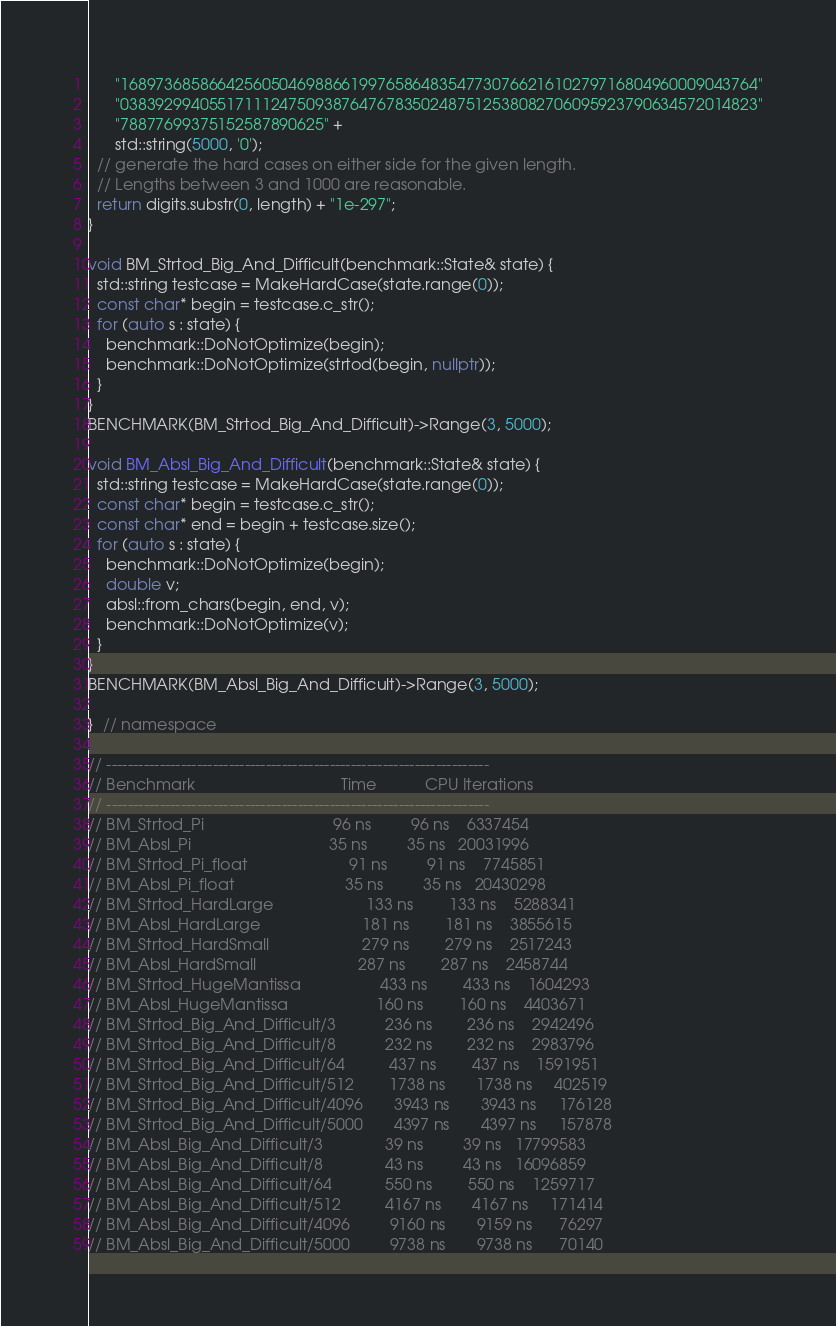<code> <loc_0><loc_0><loc_500><loc_500><_C++_>      "168973685866425605046988661997658648354773076621610279716804960009043764"
      "038392994055171112475093876476783502487512538082706095923790634572014823"
      "78877699375152587890625" +
      std::string(5000, '0');
  // generate the hard cases on either side for the given length.
  // Lengths between 3 and 1000 are reasonable.
  return digits.substr(0, length) + "1e-297";
}

void BM_Strtod_Big_And_Difficult(benchmark::State& state) {
  std::string testcase = MakeHardCase(state.range(0));
  const char* begin = testcase.c_str();
  for (auto s : state) {
    benchmark::DoNotOptimize(begin);
    benchmark::DoNotOptimize(strtod(begin, nullptr));
  }
}
BENCHMARK(BM_Strtod_Big_And_Difficult)->Range(3, 5000);

void BM_Absl_Big_And_Difficult(benchmark::State& state) {
  std::string testcase = MakeHardCase(state.range(0));
  const char* begin = testcase.c_str();
  const char* end = begin + testcase.size();
  for (auto s : state) {
    benchmark::DoNotOptimize(begin);
    double v;
    absl::from_chars(begin, end, v);
    benchmark::DoNotOptimize(v);
  }
}
BENCHMARK(BM_Absl_Big_And_Difficult)->Range(3, 5000);

}  // namespace

// ------------------------------------------------------------------------
// Benchmark                                 Time           CPU Iterations
// ------------------------------------------------------------------------
// BM_Strtod_Pi                             96 ns         96 ns    6337454
// BM_Absl_Pi                               35 ns         35 ns   20031996
// BM_Strtod_Pi_float                       91 ns         91 ns    7745851
// BM_Absl_Pi_float                         35 ns         35 ns   20430298
// BM_Strtod_HardLarge                     133 ns        133 ns    5288341
// BM_Absl_HardLarge                       181 ns        181 ns    3855615
// BM_Strtod_HardSmall                     279 ns        279 ns    2517243
// BM_Absl_HardSmall                       287 ns        287 ns    2458744
// BM_Strtod_HugeMantissa                  433 ns        433 ns    1604293
// BM_Absl_HugeMantissa                    160 ns        160 ns    4403671
// BM_Strtod_Big_And_Difficult/3           236 ns        236 ns    2942496
// BM_Strtod_Big_And_Difficult/8           232 ns        232 ns    2983796
// BM_Strtod_Big_And_Difficult/64          437 ns        437 ns    1591951
// BM_Strtod_Big_And_Difficult/512        1738 ns       1738 ns     402519
// BM_Strtod_Big_And_Difficult/4096       3943 ns       3943 ns     176128
// BM_Strtod_Big_And_Difficult/5000       4397 ns       4397 ns     157878
// BM_Absl_Big_And_Difficult/3              39 ns         39 ns   17799583
// BM_Absl_Big_And_Difficult/8              43 ns         43 ns   16096859
// BM_Absl_Big_And_Difficult/64            550 ns        550 ns    1259717
// BM_Absl_Big_And_Difficult/512          4167 ns       4167 ns     171414
// BM_Absl_Big_And_Difficult/4096         9160 ns       9159 ns      76297
// BM_Absl_Big_And_Difficult/5000         9738 ns       9738 ns      70140
</code> 